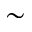<formula> <loc_0><loc_0><loc_500><loc_500>\sim</formula> 